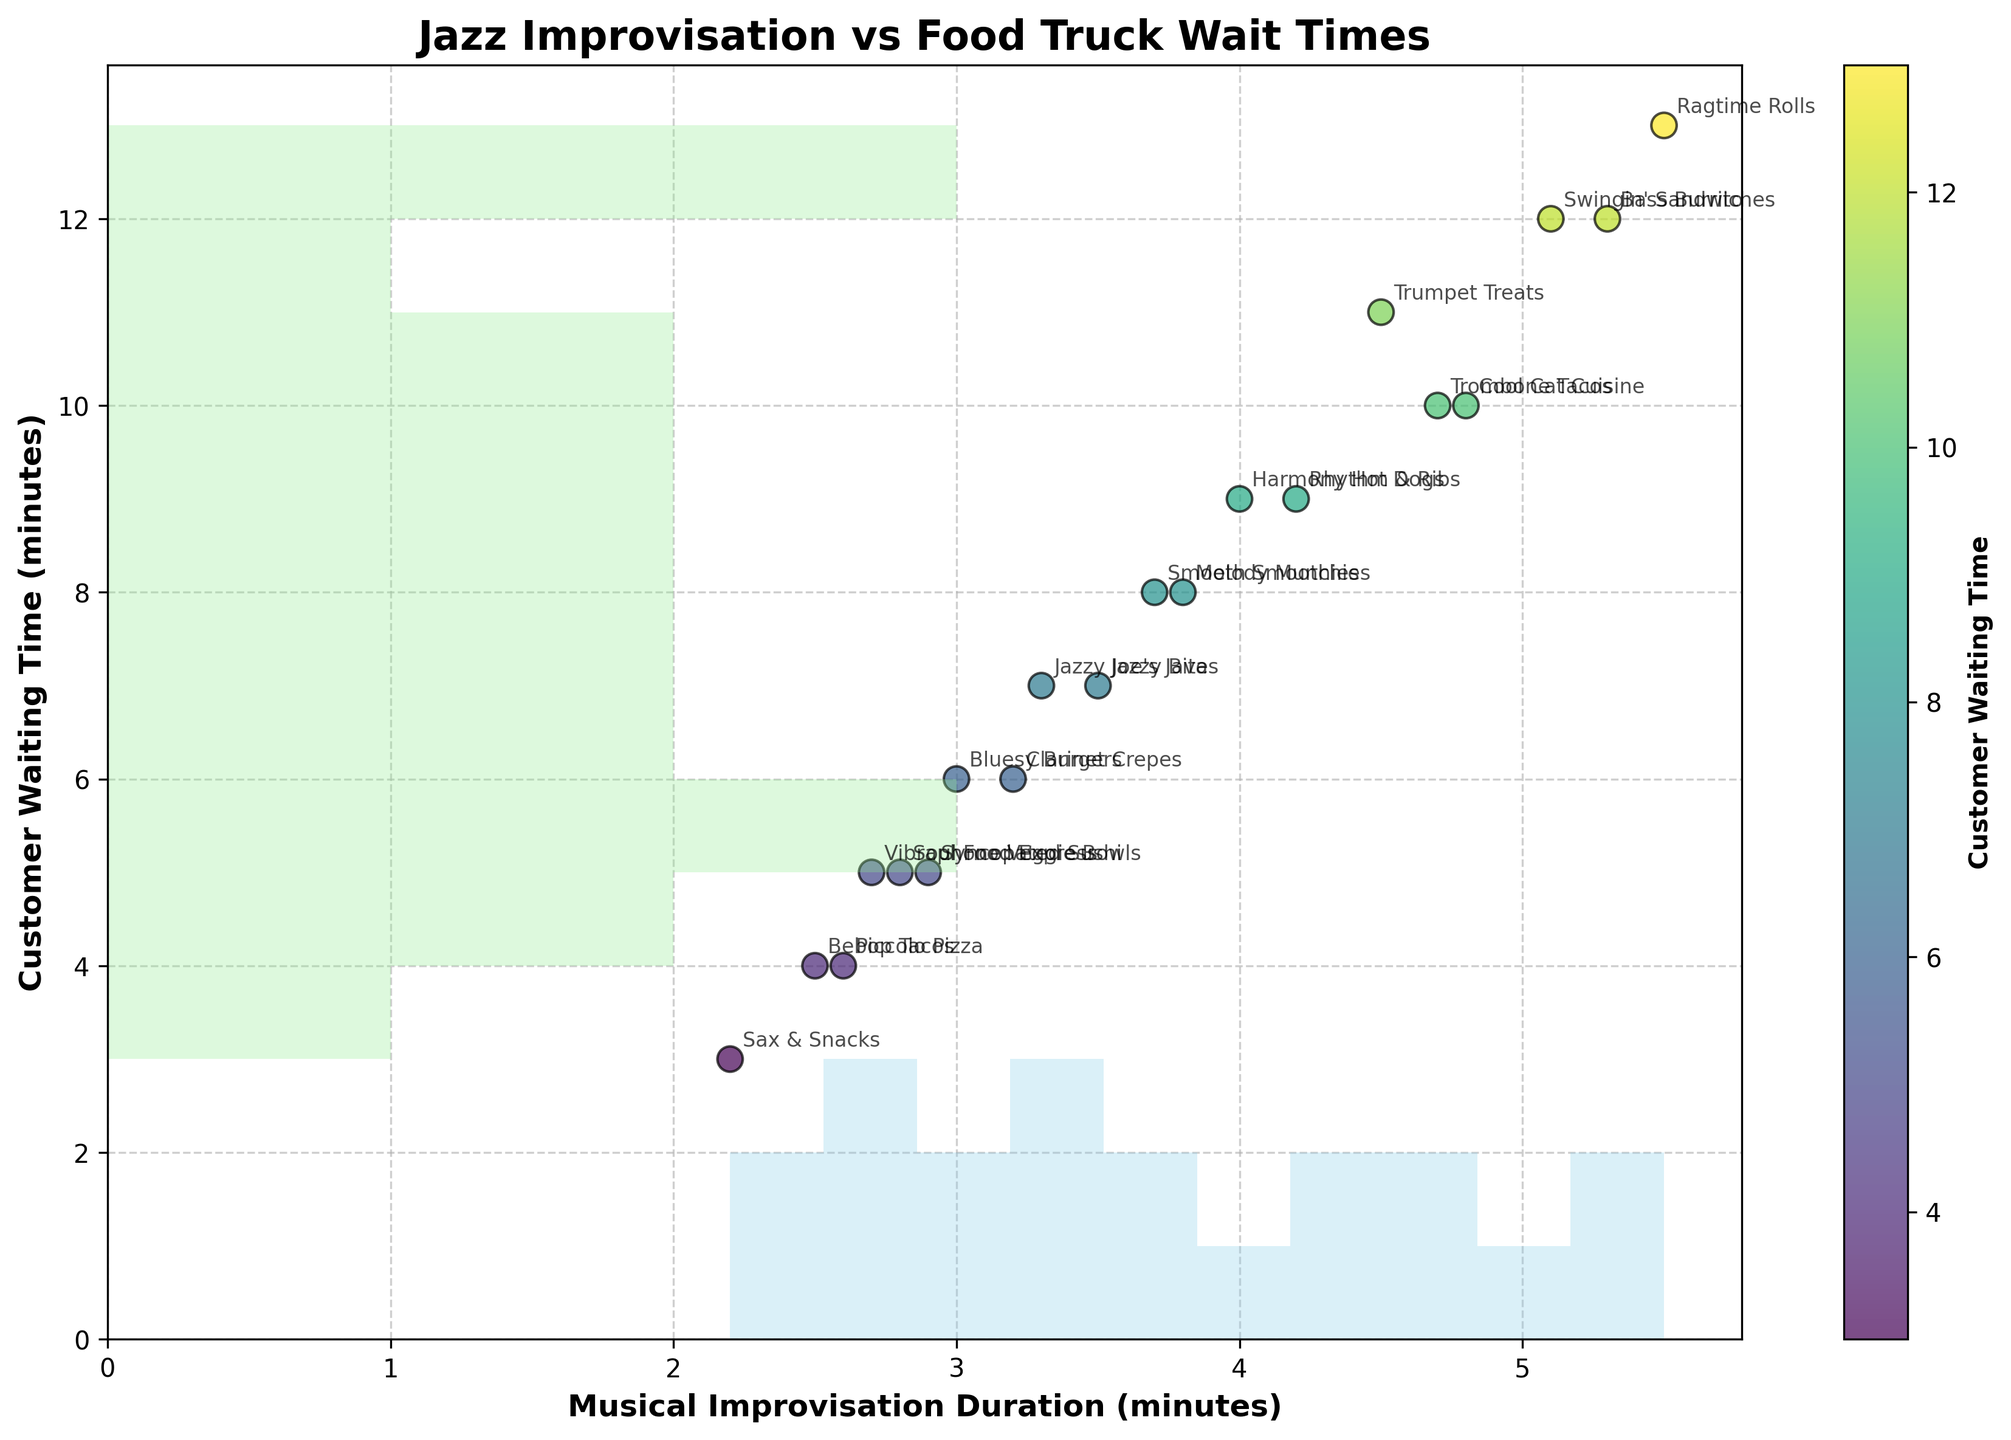What's the title of the figure? The title of the figure is typically placed at the top and provides a brief description of what the plot represents. In this case, it is the text in large, bold font at the top.
Answer: Jazz Improvisation vs Food Truck Wait Times What is the range of the X-axis representing musical improvisation duration? The X-axis represents musical improvisation duration in minutes, which can be determined by looking at the lowest and highest values along the horizontal axis.
Answer: 2.2 to 5.5 Which food truck has the longest customer waiting time? By checking the data points and annotations on the scatterplot, the food truck with the highest Y-axis value represents the longest waiting time.
Answer: Ragtime Rolls How many food trucks have musical improvisation durations of more than 4 minutes? Count the number of data points (scatter points) that have their X-axis values greater than 4. Each of these points represents a food truck with a musical improvisation duration over 4 minutes.
Answer: 8 trucks Which food truck has the shortest musical improvisation duration and what is it? By identifying the data point farthest to the left on the X-axis, the corresponding annotation will indicate the food truck with the shortest duration.
Answer: Sax & Snacks: 2.2 minutes What's the average customer waiting time for food trucks with an improvisation duration between 3 and 4 minutes? First identify the points within the range of 3 to 4 minutes on the X-axis, then calculate the average Y-axis values (customer waiting times) of these points.
Answer: 6.5 minutes Is there a visible correlation between musical improvisation duration and customer waiting time? Observe the general trend of how data points are distributed on the scatterplot. If the points tend to move in one direction (upward or downward), there may be a correlation.
Answer: Positive correlation What's the bin count for customer waiting times in the range of 3 to 5 minutes on the histogram? Check the histogram on the Y-axis for the bar that falls within the 3 to 5 minute range and count the number of occurrences in that bin.
Answer: 2 occurrences Which two food trucks have nearly identical musical improvisation durations but very different waiting times? Look for data points that are horizontally close to each other (similar X-axis values) but vertically far apart (different Y-axis values).
Answer: Bluesy Burgers and Melody Munchies What is the relationship between "Trumpet Treats" and "Cool Cat Cuisine" in terms of improvisation duration and waiting time? Identify the corresponding data points and compare their X and Y values to understand how one food truck's improvisation duration and waiting time relate to the other's.
Answer: Trumpet Treats has longer waiting time but shorter improvisation duration 